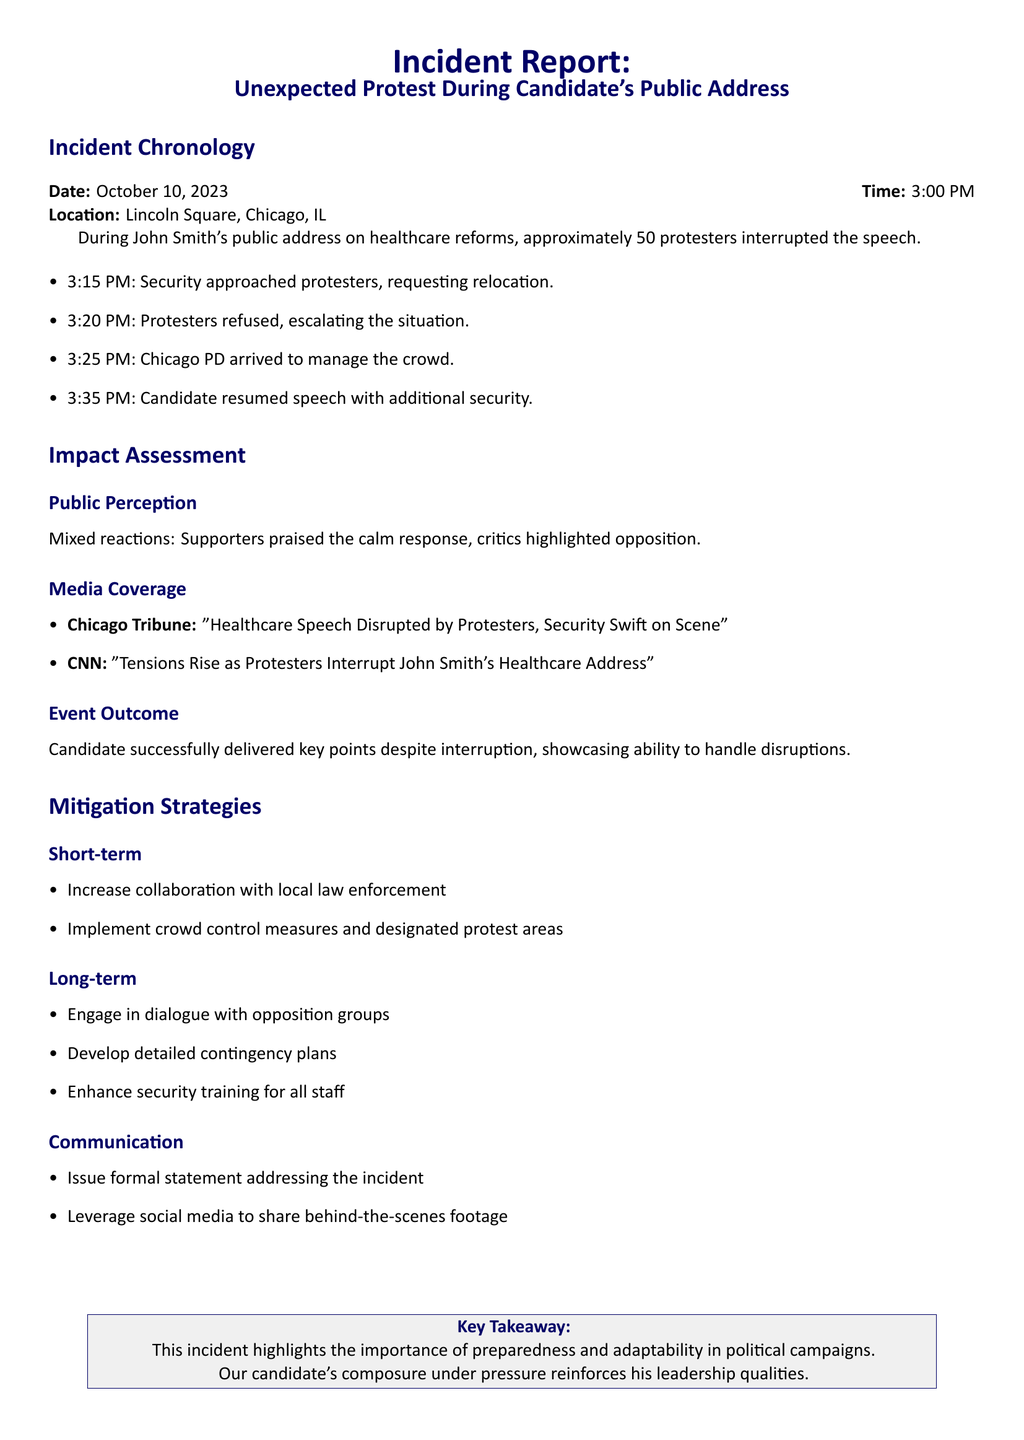What was the date of the incident? The date of the incident is explicitly stated in the chronology section of the document.
Answer: October 10, 2023 How many protesters interrupted the speech? The document specifies the number of protesters during the incident in the chronology section.
Answer: approximately 50 What time did the Chicago PD arrive? The arrival time of the police is noted in the incident chronology.
Answer: 3:25 PM What was the media coverage headline from CNN? The specific headline from CNN regarding the incident is included in the media coverage section.
Answer: Tensions Rise as Protesters Interrupt John Smith's Healthcare Address What was the key takeaway from the incident report? The key takeaway is highlighted in a specific section summarizing the overall lesson from the incident.
Answer: This incident highlights the importance of preparedness and adaptability in political campaigns What is one short-term mitigation strategy mentioned? The report lists specific mitigation strategies categorized into short-term and long-term; one example is requested.
Answer: Increase collaboration with local law enforcement What did supporters praise in response to the incident? The impact assessment section notes the reactions from supporters and critics about the incident.
Answer: calm response What demonstrates the candidate's ability to handle disruptions? The outcome of the event highlights how the candidate managed the unexpected situation.
Answer: successfully delivered key points despite interruption 